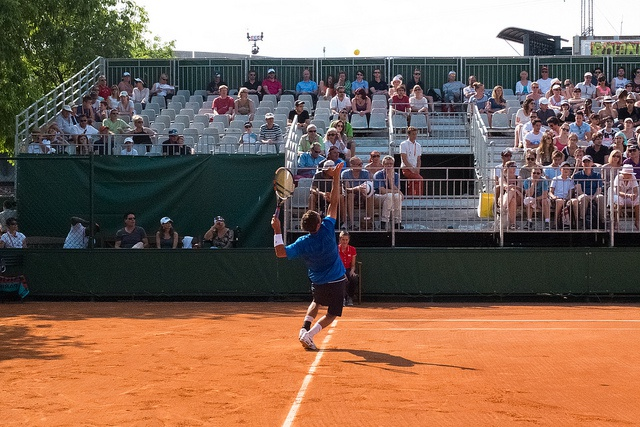Describe the objects in this image and their specific colors. I can see people in darkgreen, gray, black, and darkgray tones, chair in darkgreen, gray, and darkgray tones, people in darkgreen, black, navy, maroon, and brown tones, people in darkgreen, gray, maroon, black, and navy tones, and people in darkgreen, maroon, darkgray, and brown tones in this image. 